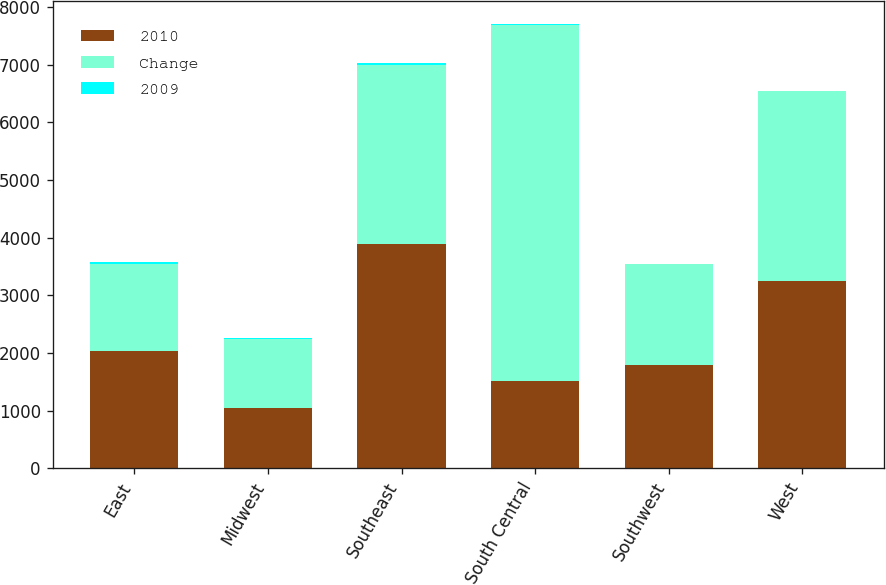<chart> <loc_0><loc_0><loc_500><loc_500><stacked_bar_chart><ecel><fcel>East<fcel>Midwest<fcel>Southeast<fcel>South Central<fcel>Southwest<fcel>West<nl><fcel>2010<fcel>2027<fcel>1045<fcel>3892<fcel>1519<fcel>1785<fcel>3251<nl><fcel>Change<fcel>1519<fcel>1198<fcel>3107<fcel>6172<fcel>1751<fcel>3287<nl><fcel>2009<fcel>33<fcel>13<fcel>25<fcel>19<fcel>2<fcel>1<nl></chart> 